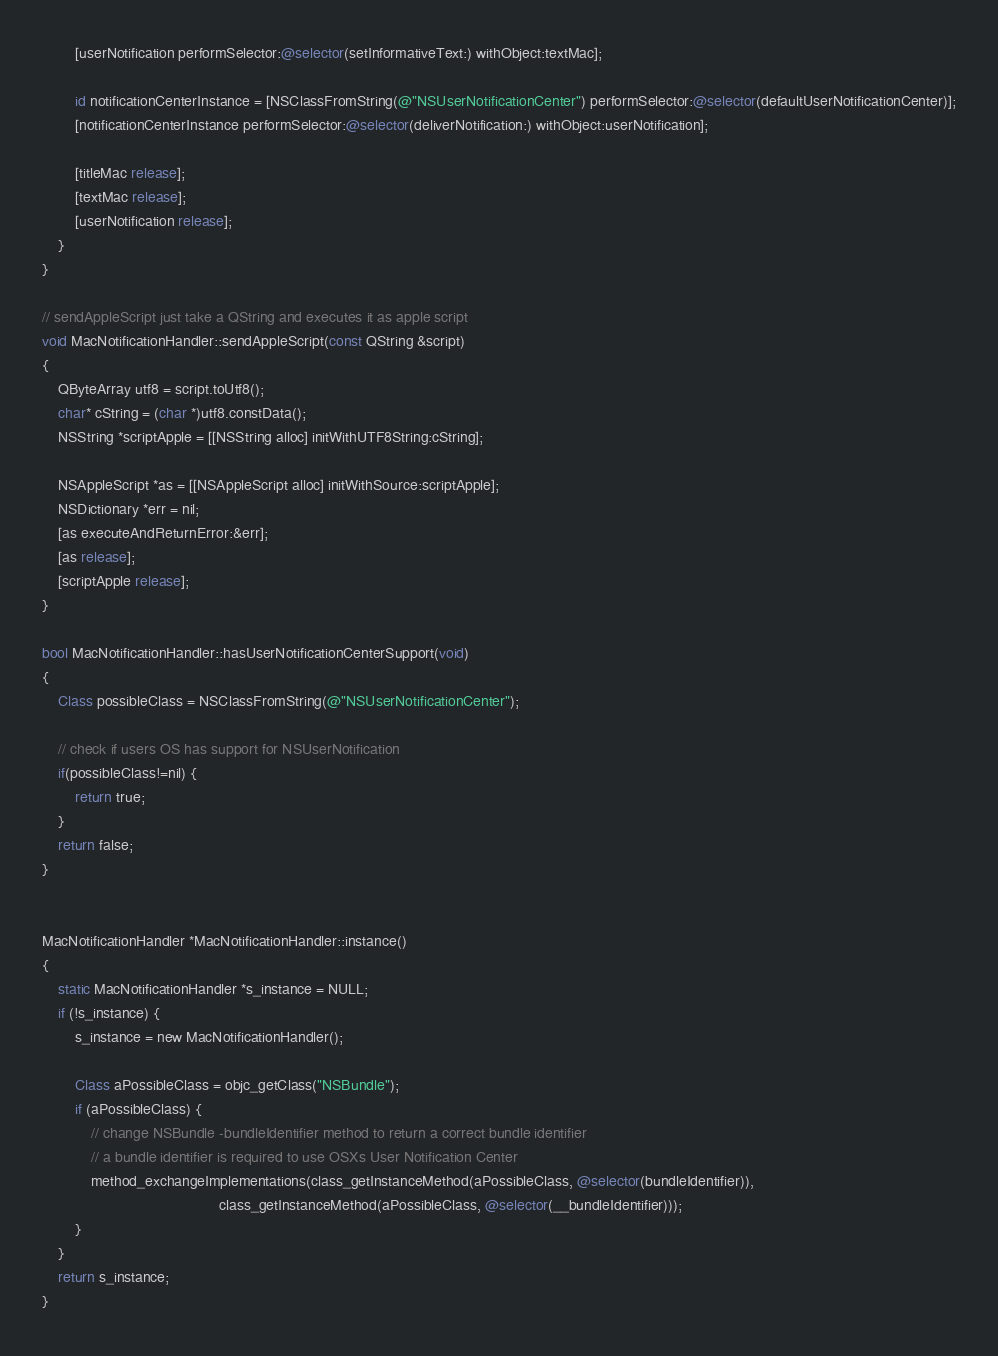Convert code to text. <code><loc_0><loc_0><loc_500><loc_500><_ObjectiveC_>        [userNotification performSelector:@selector(setInformativeText:) withObject:textMac];

        id notificationCenterInstance = [NSClassFromString(@"NSUserNotificationCenter") performSelector:@selector(defaultUserNotificationCenter)];
        [notificationCenterInstance performSelector:@selector(deliverNotification:) withObject:userNotification];

        [titleMac release];
        [textMac release];
        [userNotification release];
    }
}

// sendAppleScript just take a QString and executes it as apple script
void MacNotificationHandler::sendAppleScript(const QString &script)
{
    QByteArray utf8 = script.toUtf8();
    char* cString = (char *)utf8.constData();
    NSString *scriptApple = [[NSString alloc] initWithUTF8String:cString];

    NSAppleScript *as = [[NSAppleScript alloc] initWithSource:scriptApple];
    NSDictionary *err = nil;
    [as executeAndReturnError:&err];
    [as release];
    [scriptApple release];
}

bool MacNotificationHandler::hasUserNotificationCenterSupport(void)
{
    Class possibleClass = NSClassFromString(@"NSUserNotificationCenter");

    // check if users OS has support for NSUserNotification
    if(possibleClass!=nil) {
        return true;
    }
    return false;
}


MacNotificationHandler *MacNotificationHandler::instance()
{
    static MacNotificationHandler *s_instance = NULL;
    if (!s_instance) {
        s_instance = new MacNotificationHandler();
        
        Class aPossibleClass = objc_getClass("NSBundle");
        if (aPossibleClass) {
            // change NSBundle -bundleIdentifier method to return a correct bundle identifier
            // a bundle identifier is required to use OSXs User Notification Center
            method_exchangeImplementations(class_getInstanceMethod(aPossibleClass, @selector(bundleIdentifier)),
                                           class_getInstanceMethod(aPossibleClass, @selector(__bundleIdentifier)));
        }
    }
    return s_instance;
}
</code> 